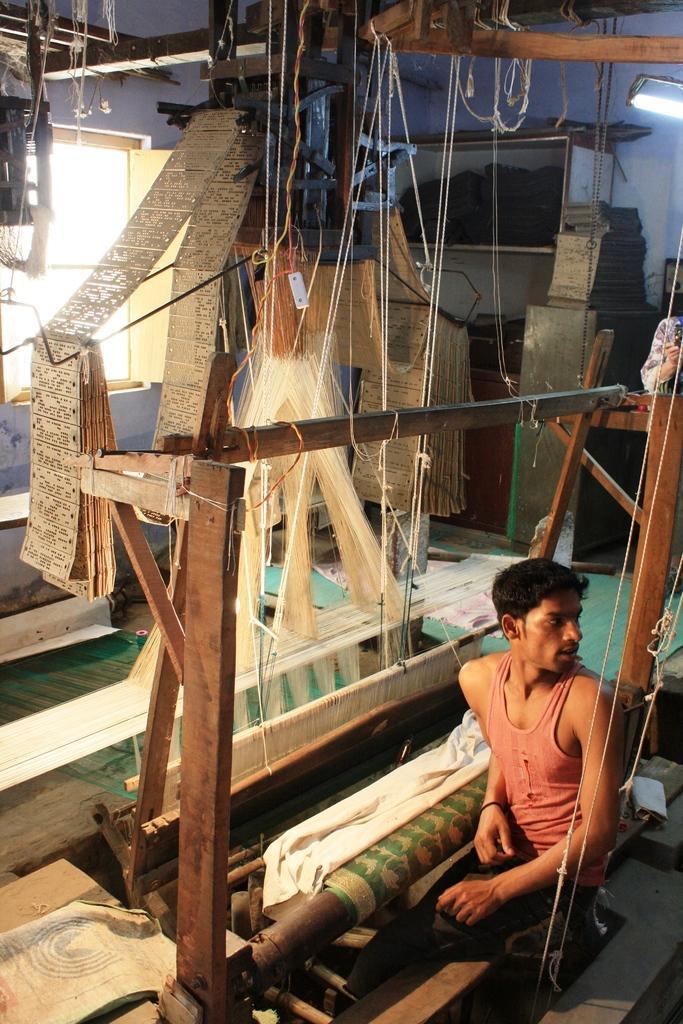In one or two sentences, can you explain what this image depicts? In the picture we can see a weaving sets in a home and a man sitting near it and turning back and in the background, we can see a wall and a light to the wall. 